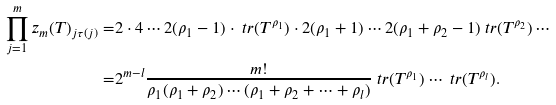Convert formula to latex. <formula><loc_0><loc_0><loc_500><loc_500>\prod _ { j = 1 } ^ { m } z _ { m } ( T ) _ { j \tau ( j ) } = & 2 \cdot 4 \cdots 2 ( \rho _ { 1 } - 1 ) \cdot \ t r ( T ^ { \rho _ { 1 } } ) \cdot 2 ( \rho _ { 1 } + 1 ) \cdots 2 ( \rho _ { 1 } + \rho _ { 2 } - 1 ) \ t r ( T ^ { \rho _ { 2 } } ) \cdots \\ = & 2 ^ { m - l } \frac { m ! } { \rho _ { 1 } ( \rho _ { 1 } + \rho _ { 2 } ) \cdots ( \rho _ { 1 } + \rho _ { 2 } + \cdots + \rho _ { l } ) } \ t r ( T ^ { \rho _ { 1 } } ) \cdots \ t r ( T ^ { \rho _ { l } } ) .</formula> 